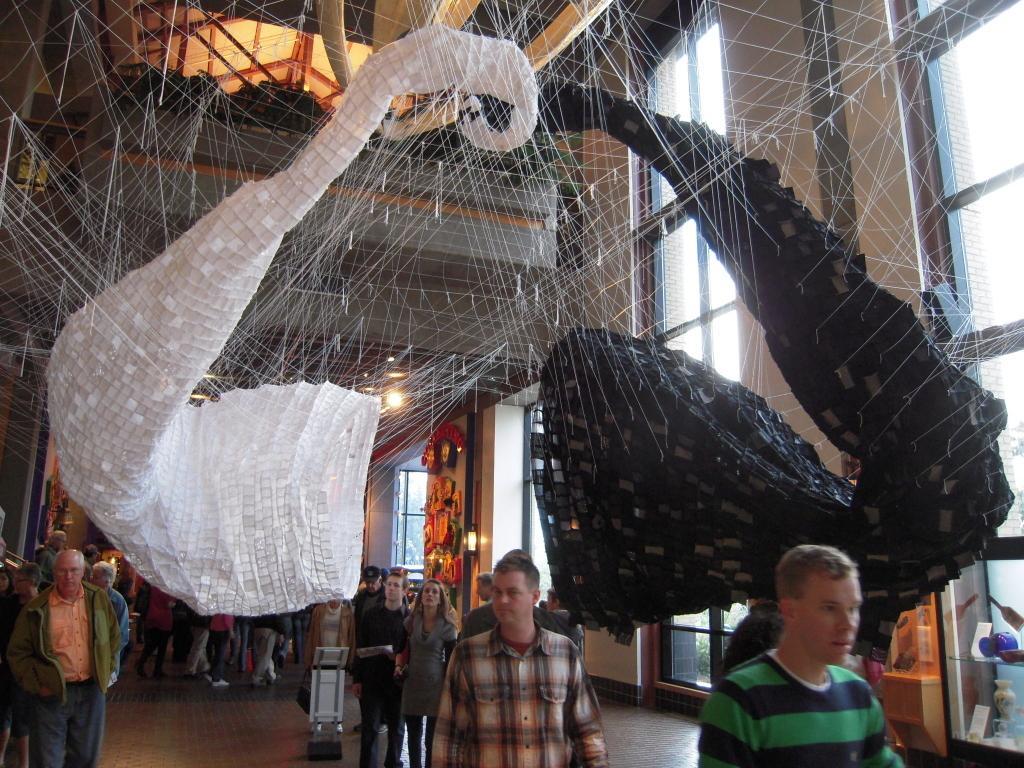Could you give a brief overview of what you see in this image? In this image, we can see some people walking and there are some windows. 